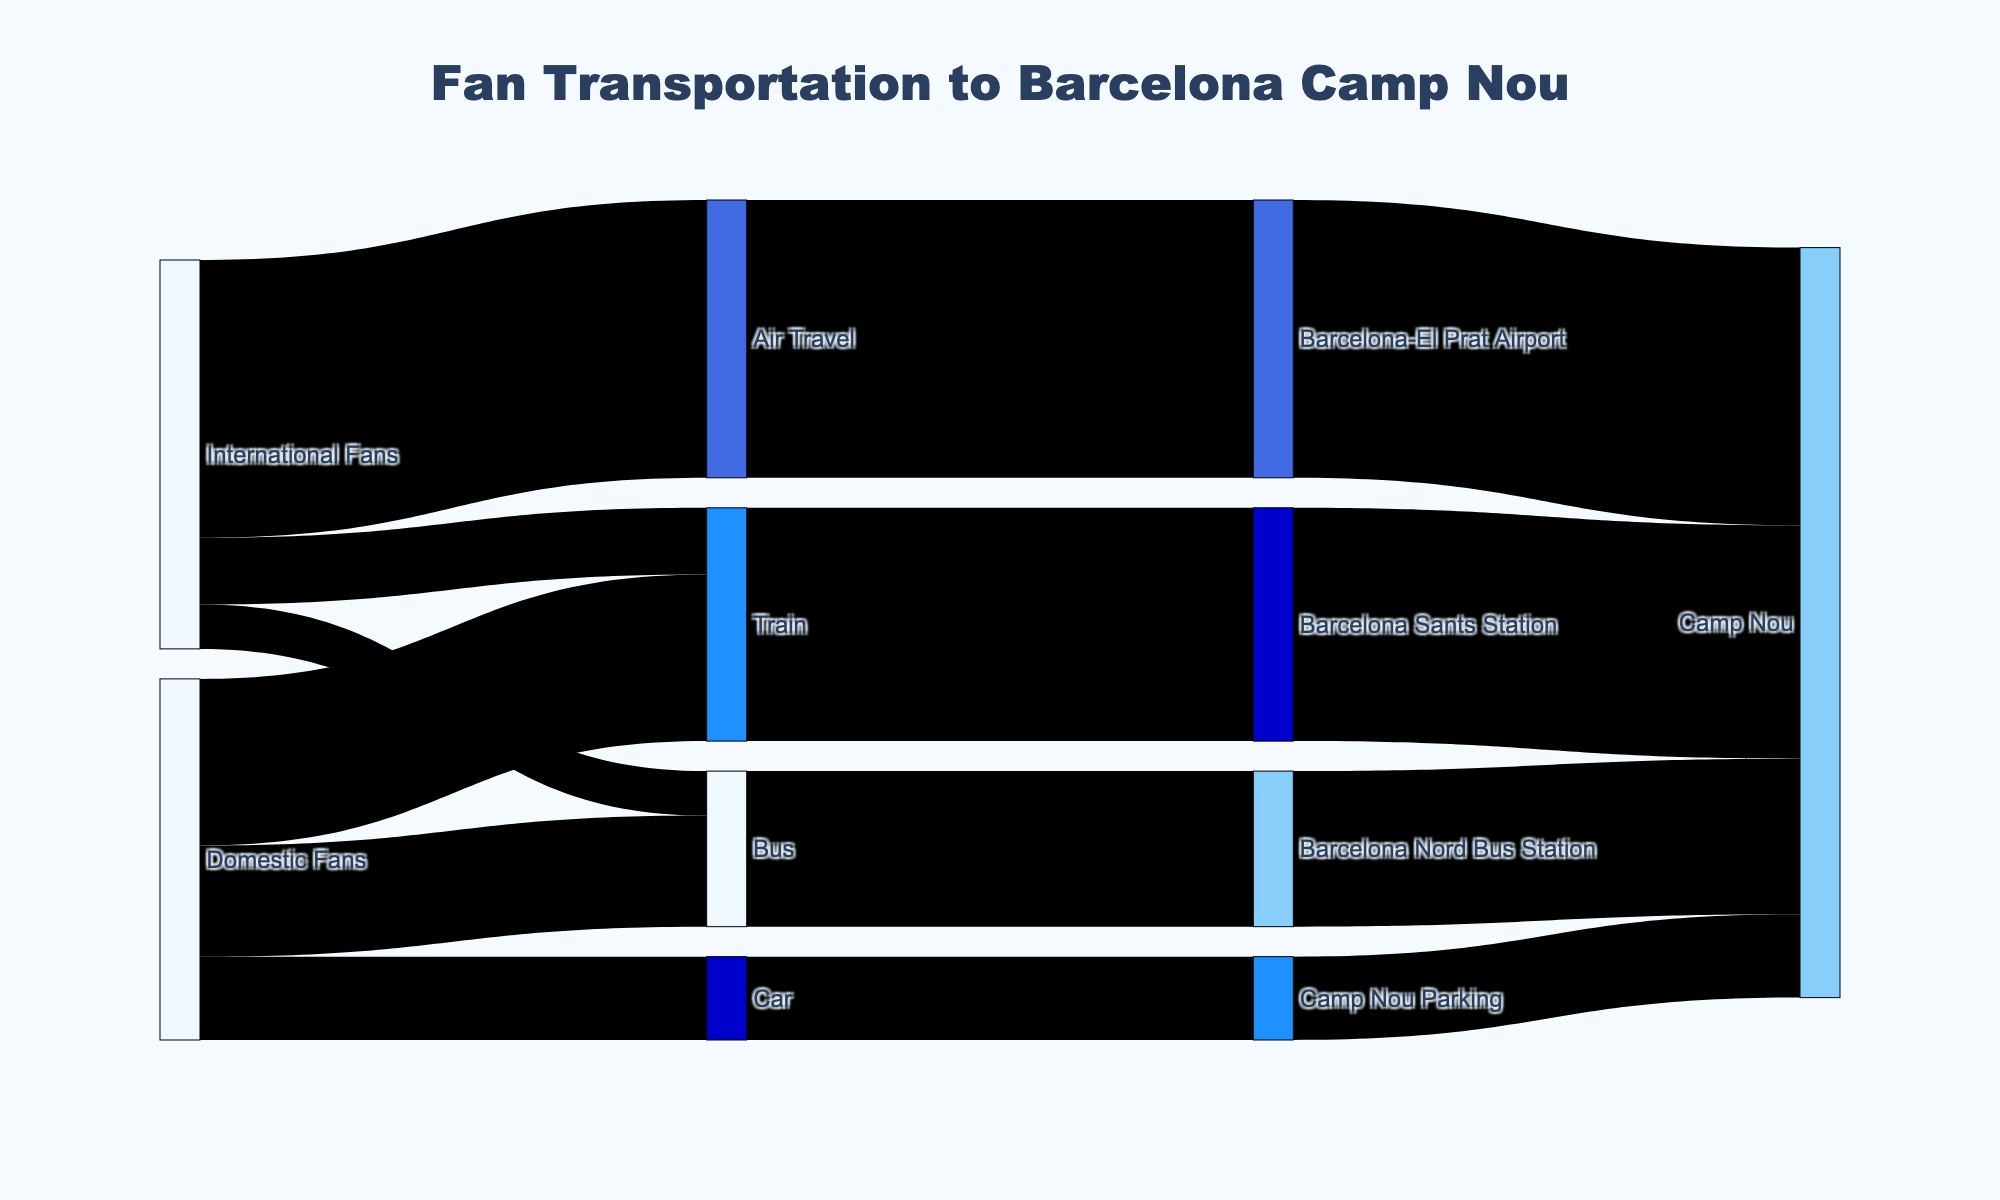What is the title of the Sankey Diagram? The title is usually found at the top center of the diagram. Here, the title is displayed as "Fan Transportation to Barcelona Camp Nou."
Answer: Fan Transportation to Barcelona Camp Nou How many transportation methods are used by international fans to reach Barcelona? From the sources connected to "International Fans," we see three methods: Air Travel, Train, and Bus.
Answer: 3 What is the total number of fans using buses to reach Barcelona? Sum the values of fans using buses from both international and domestic sources. From the diagram, we get 800 (International Fans) + 2000 (Domestic Fans) = 2800.
Answer: 2800 Which transportation method has the highest number of domestic fans? From the connections originating from "Domestic Fans," compare the values. Train (3000), Bus (2000), and Car (1500). The largest is Train with 3000.
Answer: Train How many fans in total are arriving at the Barcelona Sants Station? Sum the values leading to Barcelona Sants Station: International Fans (1200) + Domestic Fans (3000) = 4200.
Answer: 4200 Where do the fans arriving at Barcelona-El Prat Airport end up? Trace the connection from Barcelona-El Prat Airport. The diagram shows a direct link to Camp Nou.
Answer: Camp Nou How many more fans use trains than cars to reach Camp Nou? Calculate the difference between fans using trains and cars. Trains: 4200, Cars: 1500. The difference is 4200 - 1500 = 2700.
Answer: 2700 What is the total number of fans reaching Camp Nou by any means of transportation? Sum the values of all fans arriving at Camp Nou through various terminals: Barcelona-El Prat Airport (5000), Barcelona Sants Station (4200), Barcelona Nord Bus Station (2800), Camp Nou Parking (1500). Total = 5000 + 4200 + 2800 + 1500 = 13500.
Answer: 13500 Which station has the lowest number of fans arriving, and how many? Compare the values linked to each station: Barcelona-El Prat Airport (5000), Barcelona Sants Station (4200), Barcelona Nord Bus Station (2800). Barcelona Nord Bus Station has the lowest, with 2800 fans.
Answer: Barcelona Nord Bus Station, 2800 Do more international fans take flights or trains to Barcelona? Compare the values: Flights (5000) vs. Trains (1200). More international fans take flights (5000).
Answer: Flights 